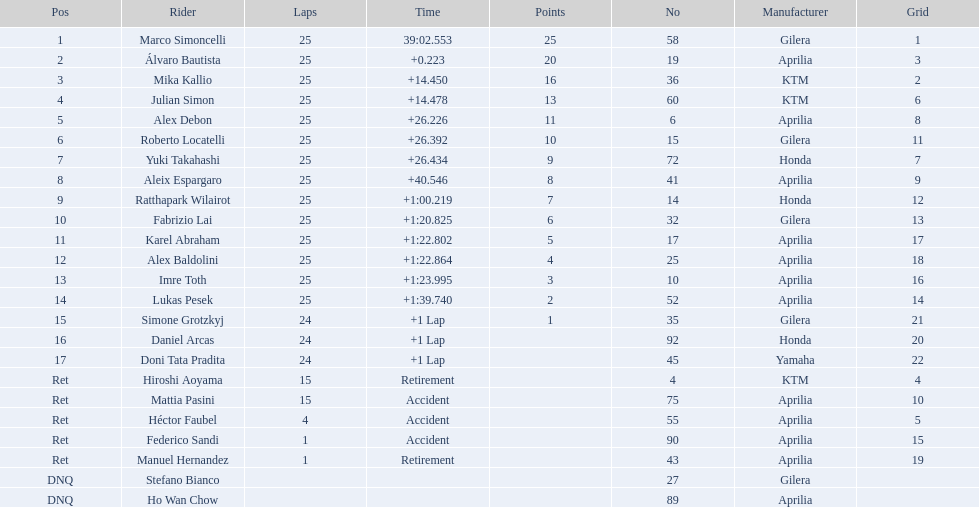What player number is marked #1 for the australian motorcycle grand prix? 58. Who is the rider that represents the #58 in the australian motorcycle grand prix? Marco Simoncelli. 